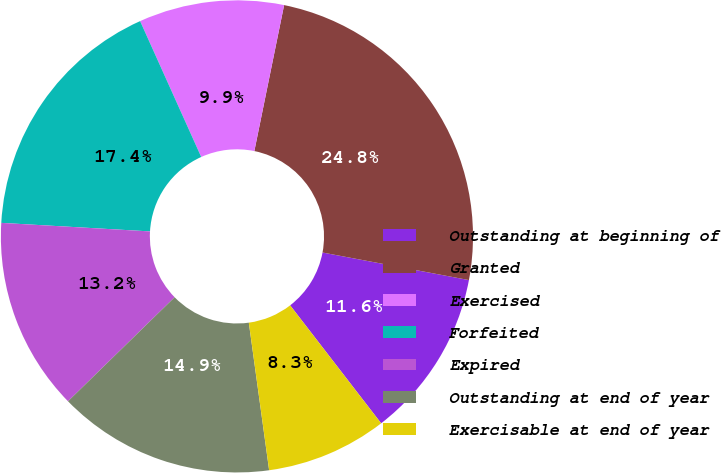<chart> <loc_0><loc_0><loc_500><loc_500><pie_chart><fcel>Outstanding at beginning of<fcel>Granted<fcel>Exercised<fcel>Forfeited<fcel>Expired<fcel>Outstanding at end of year<fcel>Exercisable at end of year<nl><fcel>11.58%<fcel>24.76%<fcel>9.93%<fcel>17.36%<fcel>13.22%<fcel>14.87%<fcel>8.28%<nl></chart> 